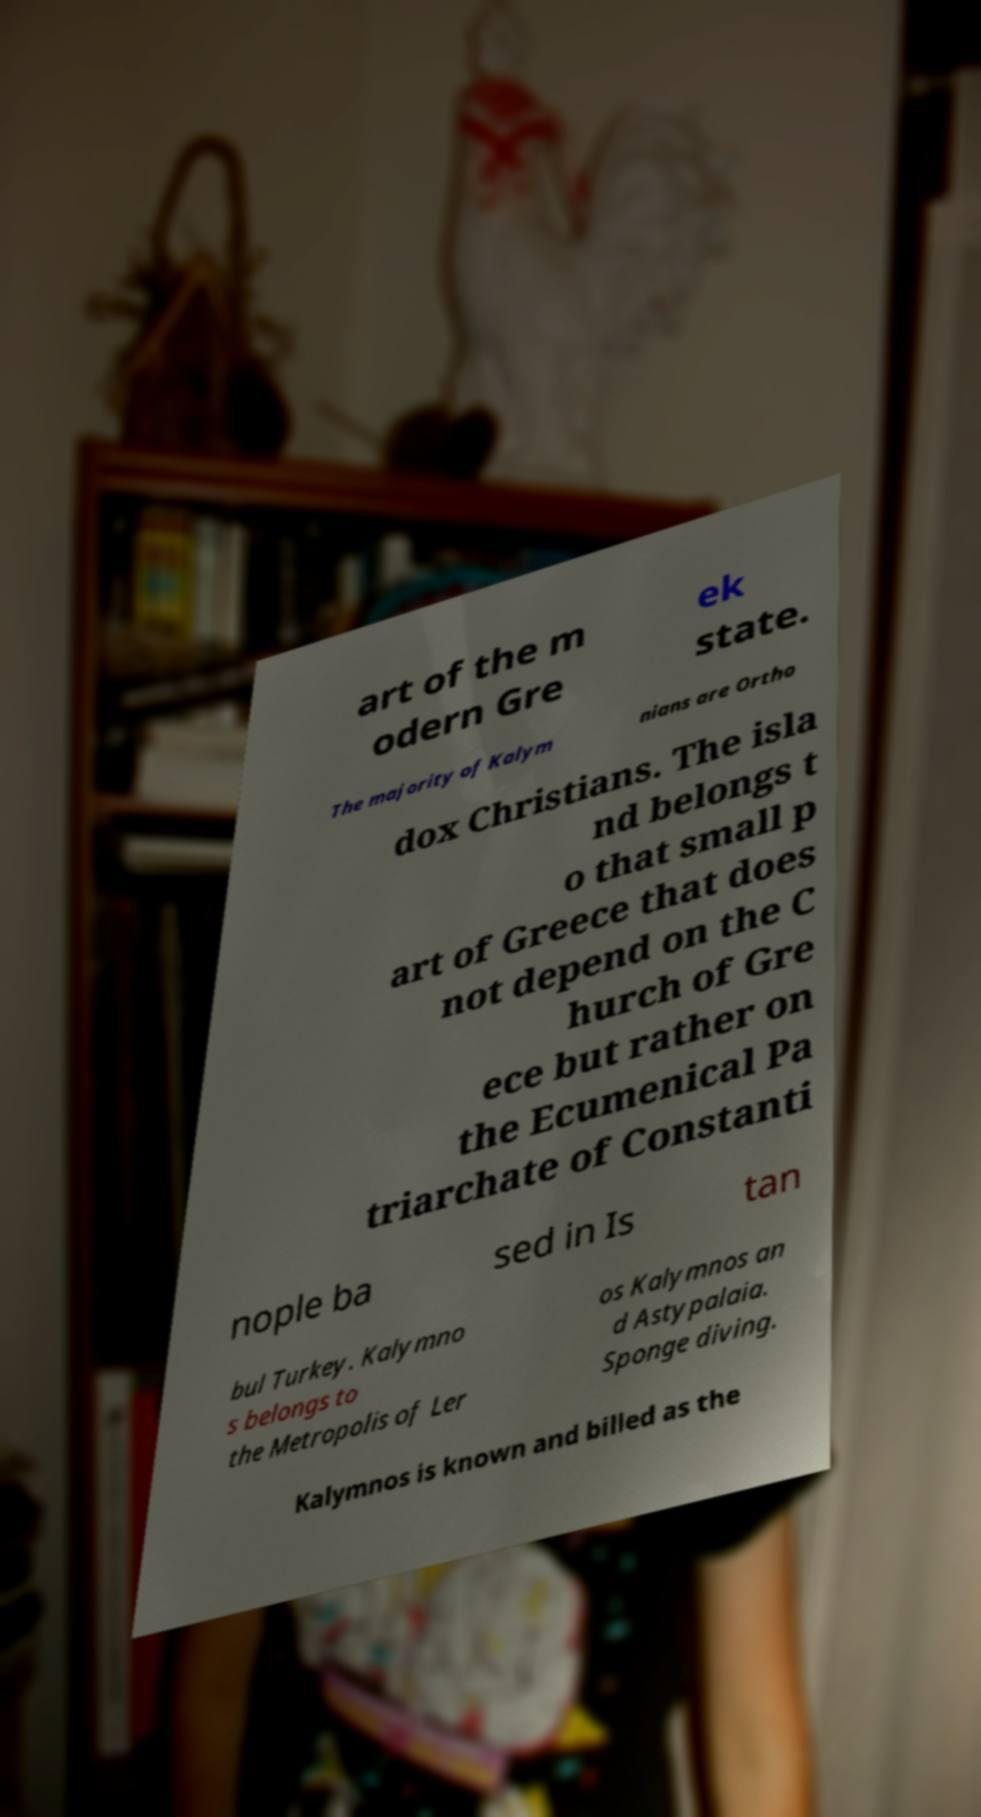Please identify and transcribe the text found in this image. art of the m odern Gre ek state. The majority of Kalym nians are Ortho dox Christians. The isla nd belongs t o that small p art of Greece that does not depend on the C hurch of Gre ece but rather on the Ecumenical Pa triarchate of Constanti nople ba sed in Is tan bul Turkey. Kalymno s belongs to the Metropolis of Ler os Kalymnos an d Astypalaia. Sponge diving. Kalymnos is known and billed as the 